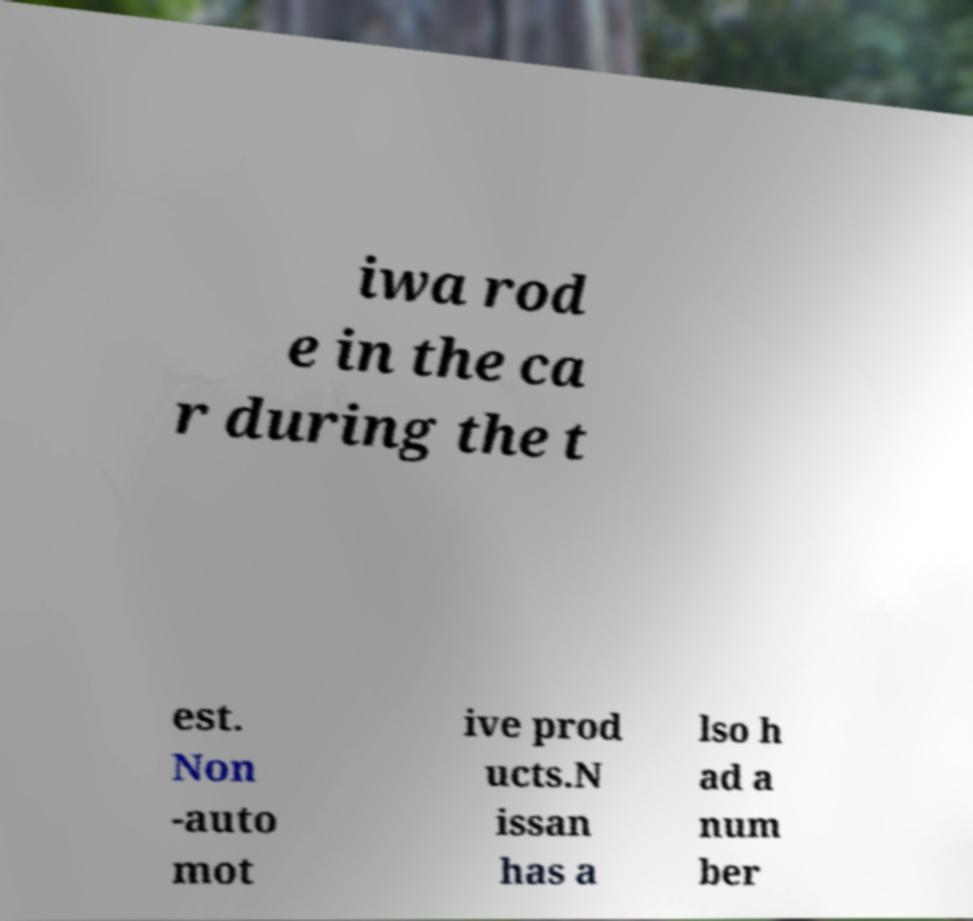Could you extract and type out the text from this image? iwa rod e in the ca r during the t est. Non -auto mot ive prod ucts.N issan has a lso h ad a num ber 